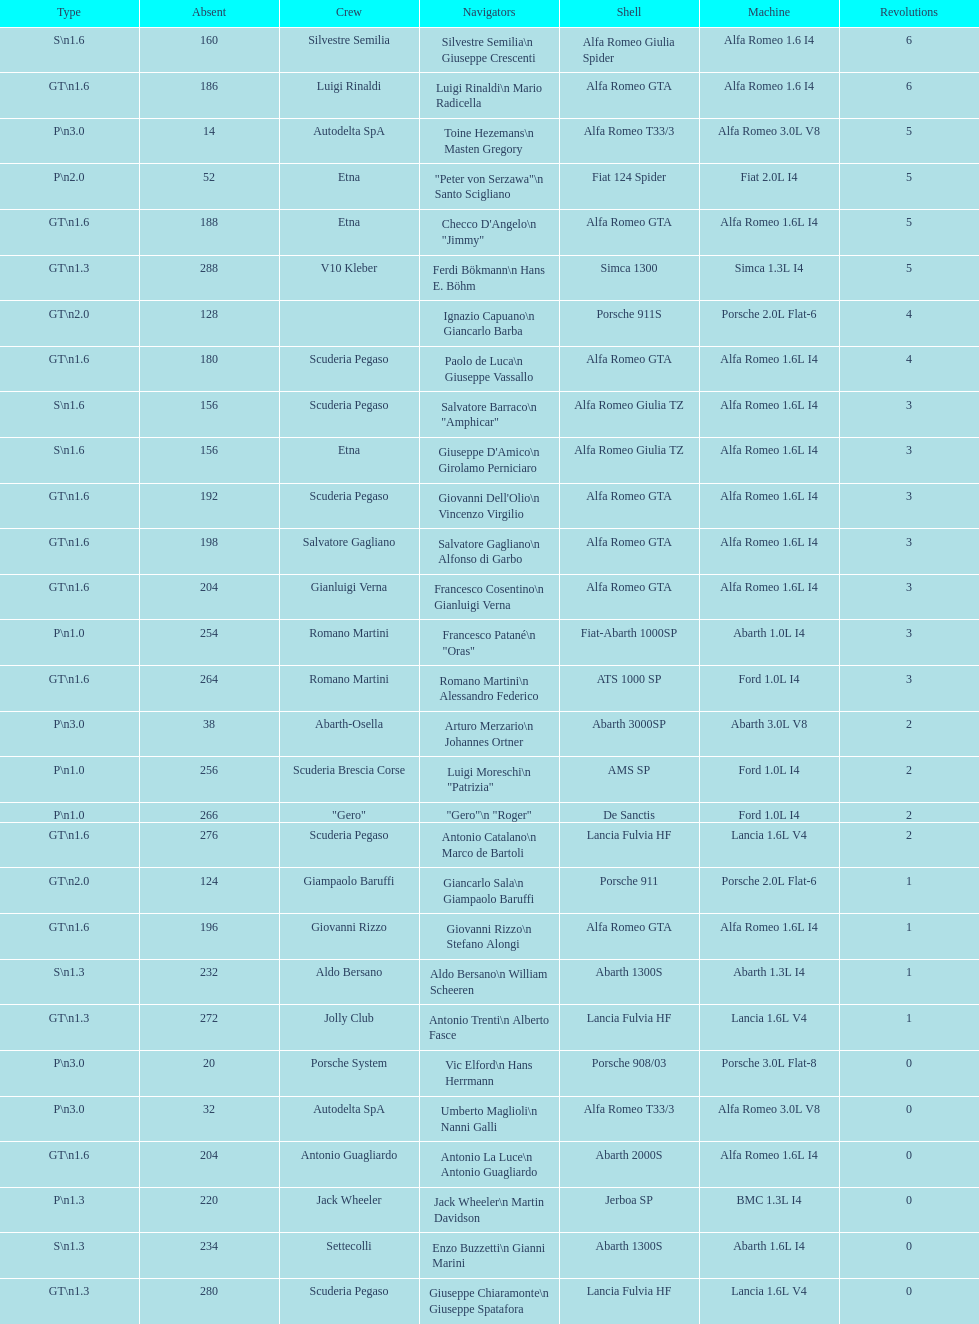Which framework is in the midst of simca 1300 and alfa romeo gta? Porsche 911S. 